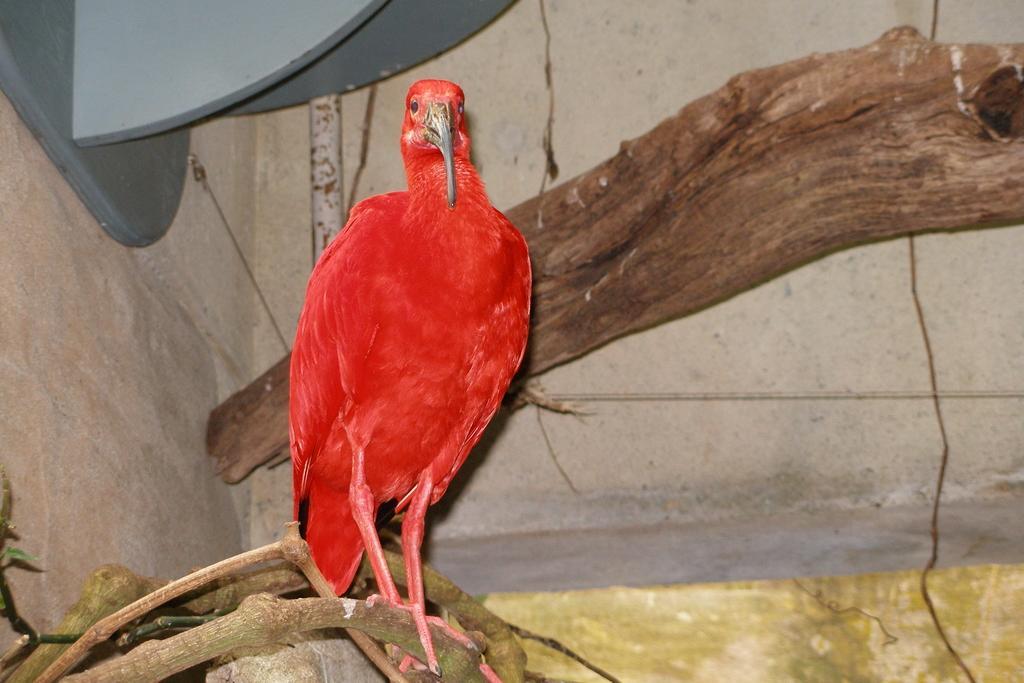Can you describe this image briefly? In the image we can see a bird, red in color. Here we can see tree branches and the wall. 